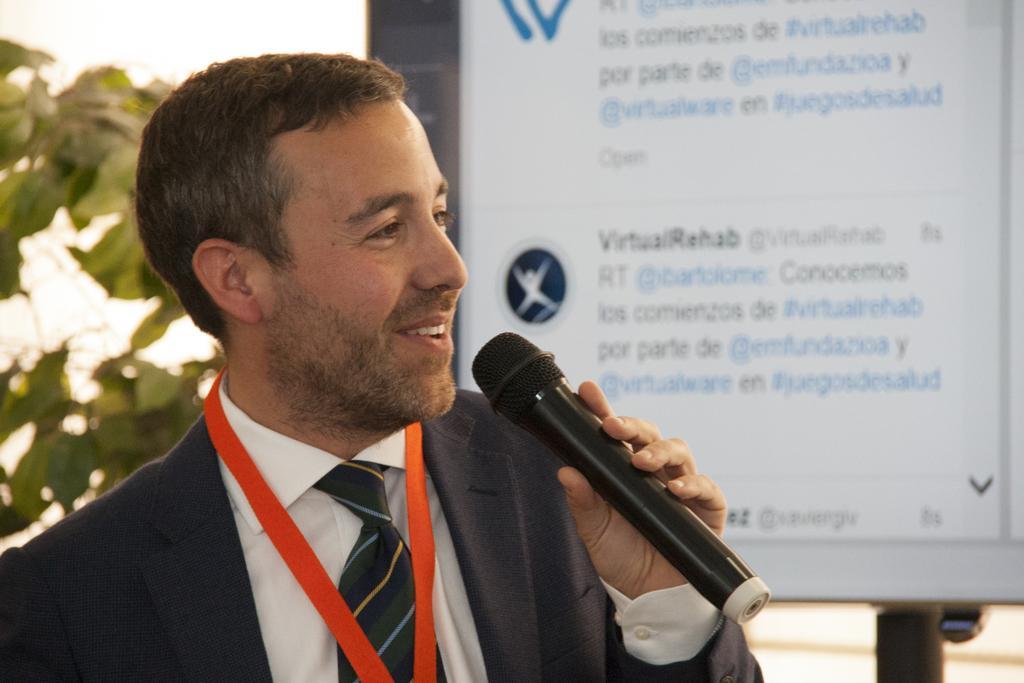Please provide a concise description of this image. As we can see in the image, there is a banner and a man holding mic. 